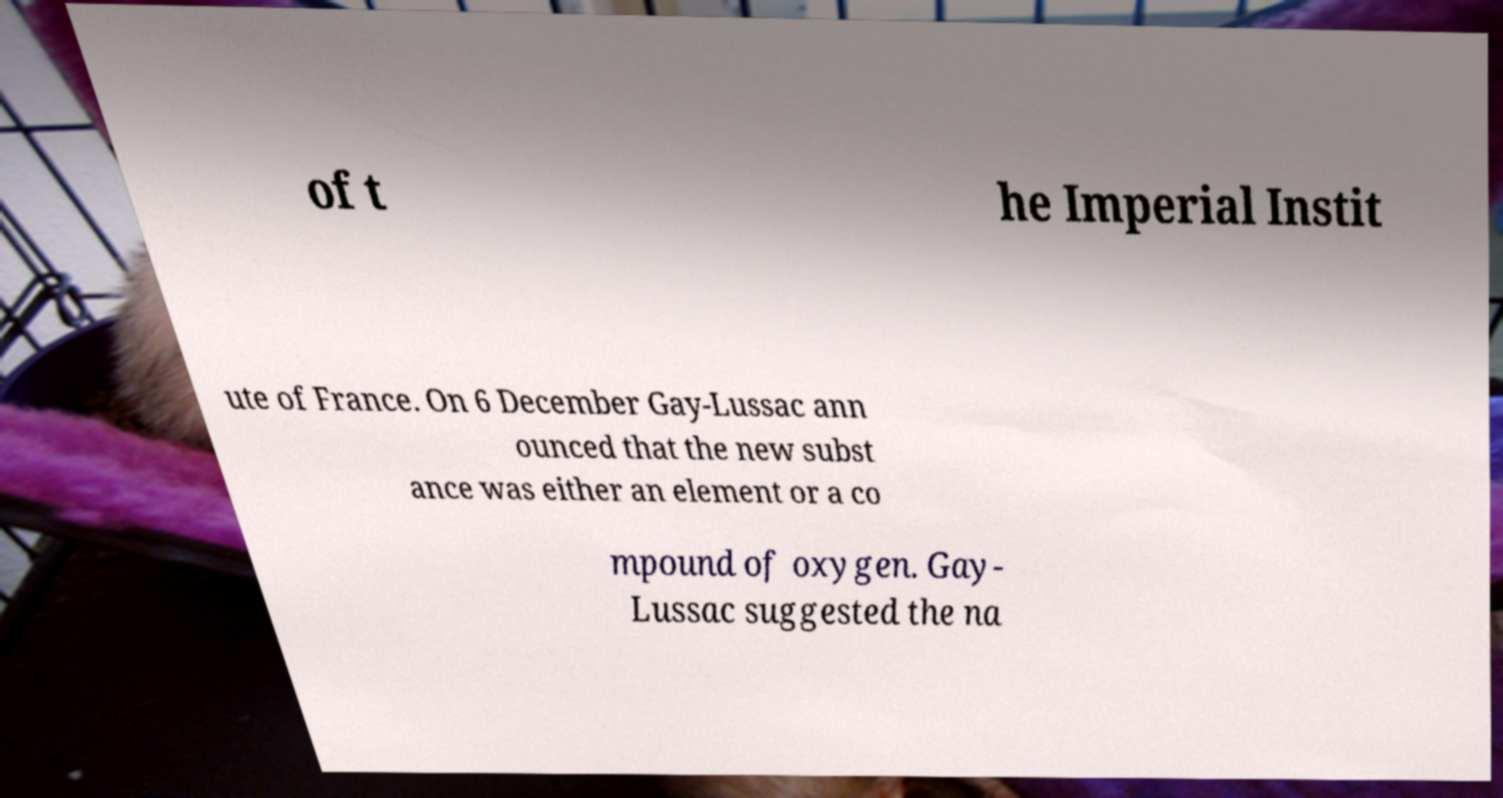Can you read and provide the text displayed in the image?This photo seems to have some interesting text. Can you extract and type it out for me? of t he Imperial Instit ute of France. On 6 December Gay-Lussac ann ounced that the new subst ance was either an element or a co mpound of oxygen. Gay- Lussac suggested the na 